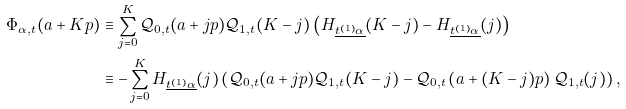Convert formula to latex. <formula><loc_0><loc_0><loc_500><loc_500>\Phi _ { \alpha , t } ( a + K p ) & \equiv \sum _ { j = 0 } ^ { K } \mathcal { Q } _ { 0 , t } ( a + j p ) \mathcal { Q } _ { 1 , t } ( K - j ) \left ( H _ { \underline { t ^ { ( 1 ) } \alpha } } ( K - j ) - H _ { \underline { t ^ { ( 1 ) } \alpha } } ( j ) \right ) \\ & \equiv - \sum _ { j = 0 } ^ { K } H _ { \underline { t ^ { ( 1 ) } \alpha } } ( j ) \left ( \mathcal { Q } _ { 0 , t } ( a + j p ) \mathcal { Q } _ { 1 , t } ( K - j ) - \mathcal { Q } _ { 0 , t } \left ( a + ( K - j ) p \right ) \mathcal { Q } _ { 1 , t } ( j ) \right ) ,</formula> 